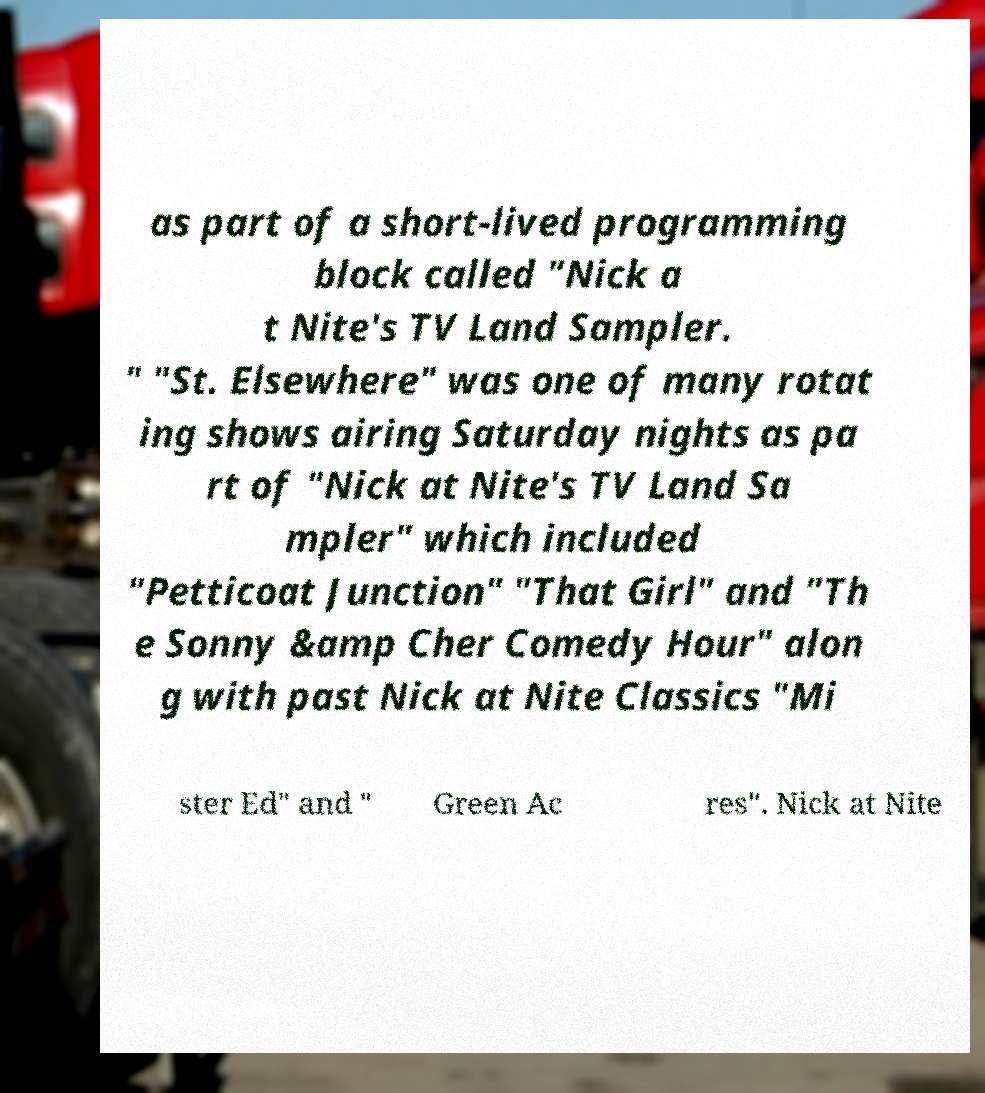Can you accurately transcribe the text from the provided image for me? as part of a short-lived programming block called "Nick a t Nite's TV Land Sampler. " "St. Elsewhere" was one of many rotat ing shows airing Saturday nights as pa rt of "Nick at Nite's TV Land Sa mpler" which included "Petticoat Junction" "That Girl" and "Th e Sonny &amp Cher Comedy Hour" alon g with past Nick at Nite Classics "Mi ster Ed" and " Green Ac res". Nick at Nite 